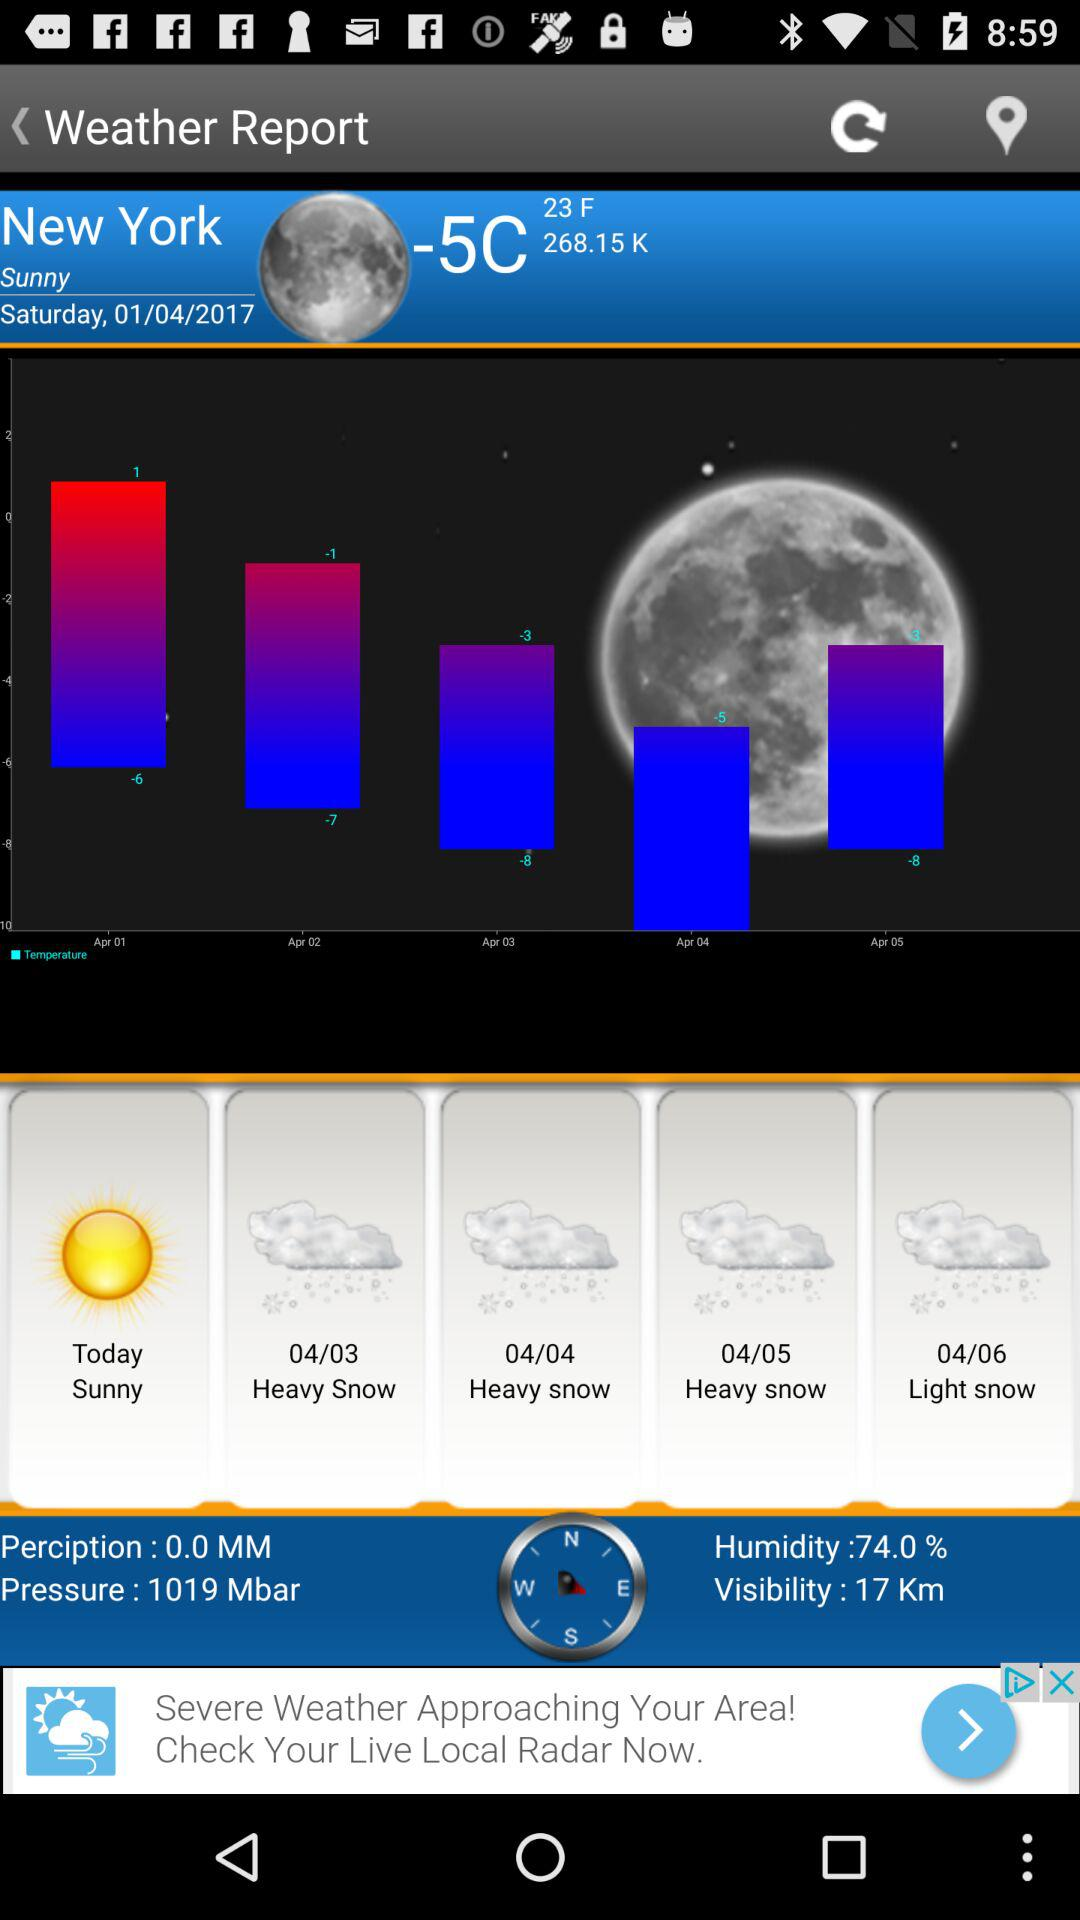How much precipitation was measured in New York today? The precipitation that was measured was 0.0 MM. 